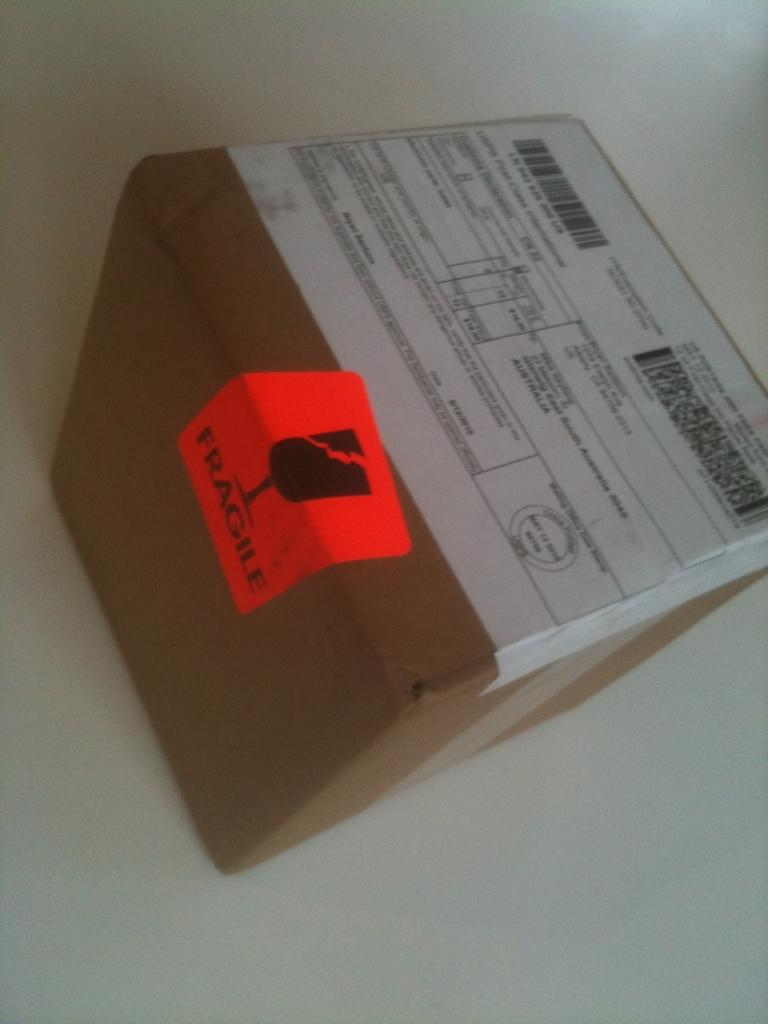<image>
Summarize the visual content of the image. a brown box with shipping labels on it and an orange label that says 'fragile' 